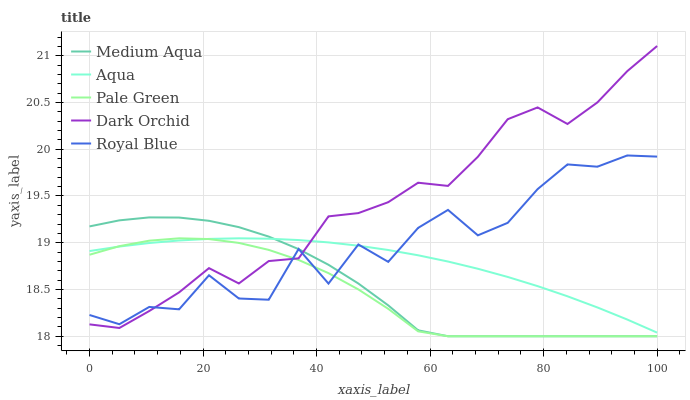Does Pale Green have the minimum area under the curve?
Answer yes or no. Yes. Does Dark Orchid have the maximum area under the curve?
Answer yes or no. Yes. Does Medium Aqua have the minimum area under the curve?
Answer yes or no. No. Does Medium Aqua have the maximum area under the curve?
Answer yes or no. No. Is Aqua the smoothest?
Answer yes or no. Yes. Is Royal Blue the roughest?
Answer yes or no. Yes. Is Pale Green the smoothest?
Answer yes or no. No. Is Pale Green the roughest?
Answer yes or no. No. Does Pale Green have the lowest value?
Answer yes or no. Yes. Does Dark Orchid have the lowest value?
Answer yes or no. No. Does Dark Orchid have the highest value?
Answer yes or no. Yes. Does Medium Aqua have the highest value?
Answer yes or no. No. Does Aqua intersect Dark Orchid?
Answer yes or no. Yes. Is Aqua less than Dark Orchid?
Answer yes or no. No. Is Aqua greater than Dark Orchid?
Answer yes or no. No. 